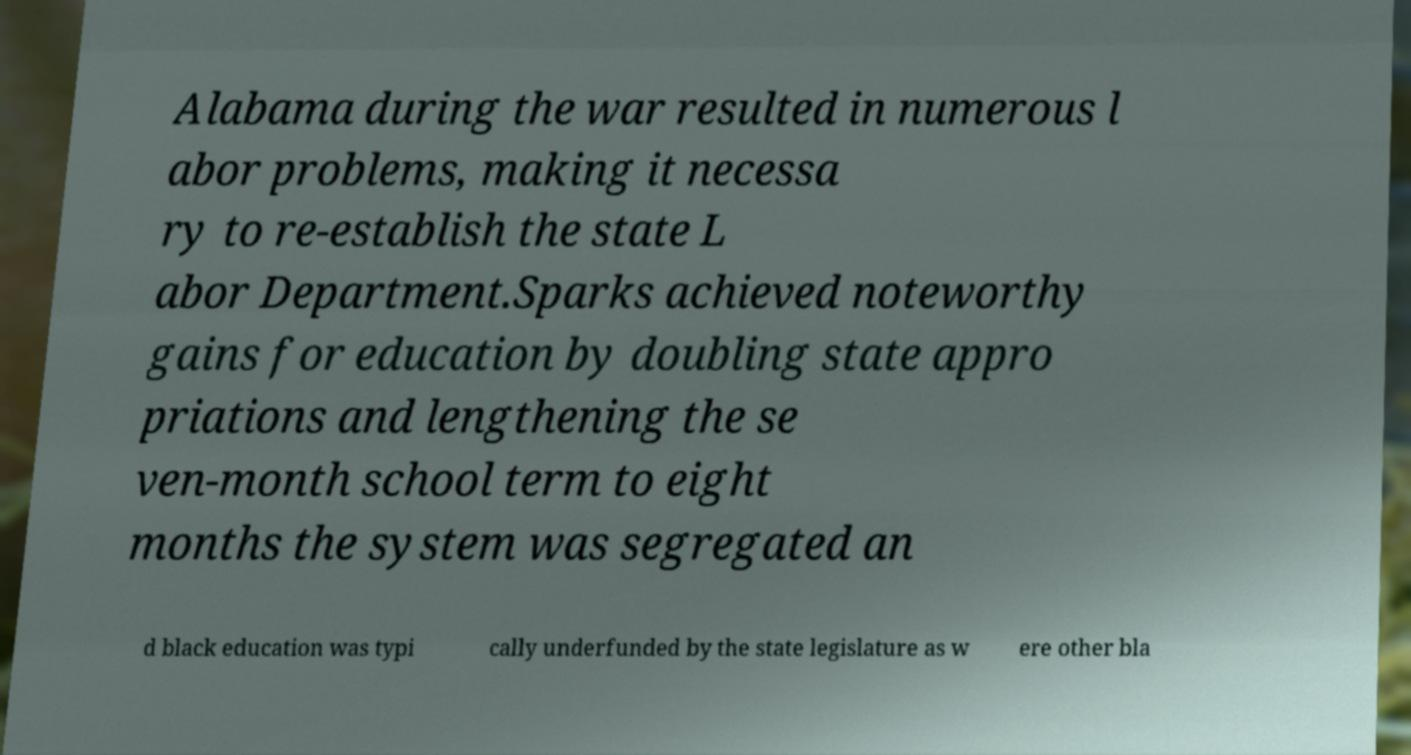For documentation purposes, I need the text within this image transcribed. Could you provide that? Alabama during the war resulted in numerous l abor problems, making it necessa ry to re-establish the state L abor Department.Sparks achieved noteworthy gains for education by doubling state appro priations and lengthening the se ven-month school term to eight months the system was segregated an d black education was typi cally underfunded by the state legislature as w ere other bla 